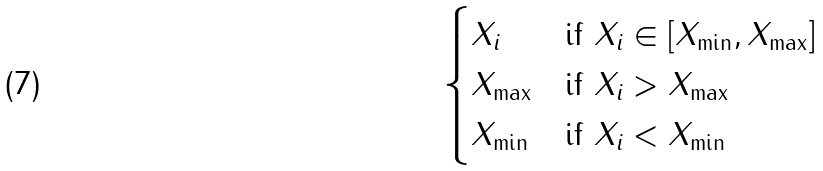<formula> <loc_0><loc_0><loc_500><loc_500>\begin{cases} X _ { i } & \text {if } X _ { i } \in [ X _ { \min } , X _ { \max } ] \\ X _ { \max } & \text {if } X _ { i } > X _ { \max } \\ X _ { \min } & \text {if } X _ { i } < X _ { \min } \end{cases}</formula> 